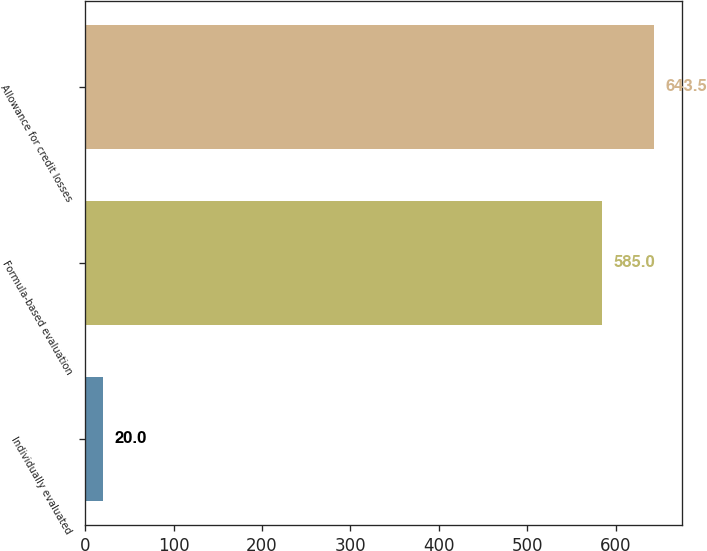<chart> <loc_0><loc_0><loc_500><loc_500><bar_chart><fcel>Individually evaluated<fcel>Formula-based evaluation<fcel>Allowance for credit losses<nl><fcel>20<fcel>585<fcel>643.5<nl></chart> 